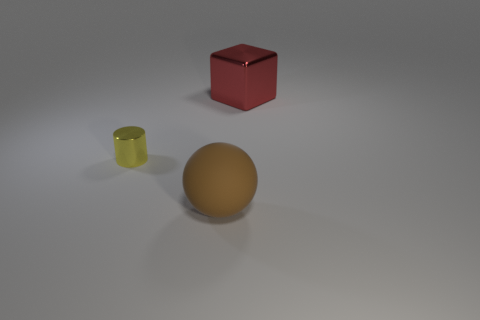Add 3 big balls. How many big balls are left? 4 Add 1 large brown rubber things. How many large brown rubber things exist? 2 Add 1 tiny brown shiny balls. How many objects exist? 4 Subtract 0 yellow balls. How many objects are left? 3 Subtract all spheres. How many objects are left? 2 Subtract 1 cylinders. How many cylinders are left? 0 Subtract all brown blocks. Subtract all green cylinders. How many blocks are left? 1 Subtract all gray cubes. How many purple balls are left? 0 Subtract all small gray objects. Subtract all big objects. How many objects are left? 1 